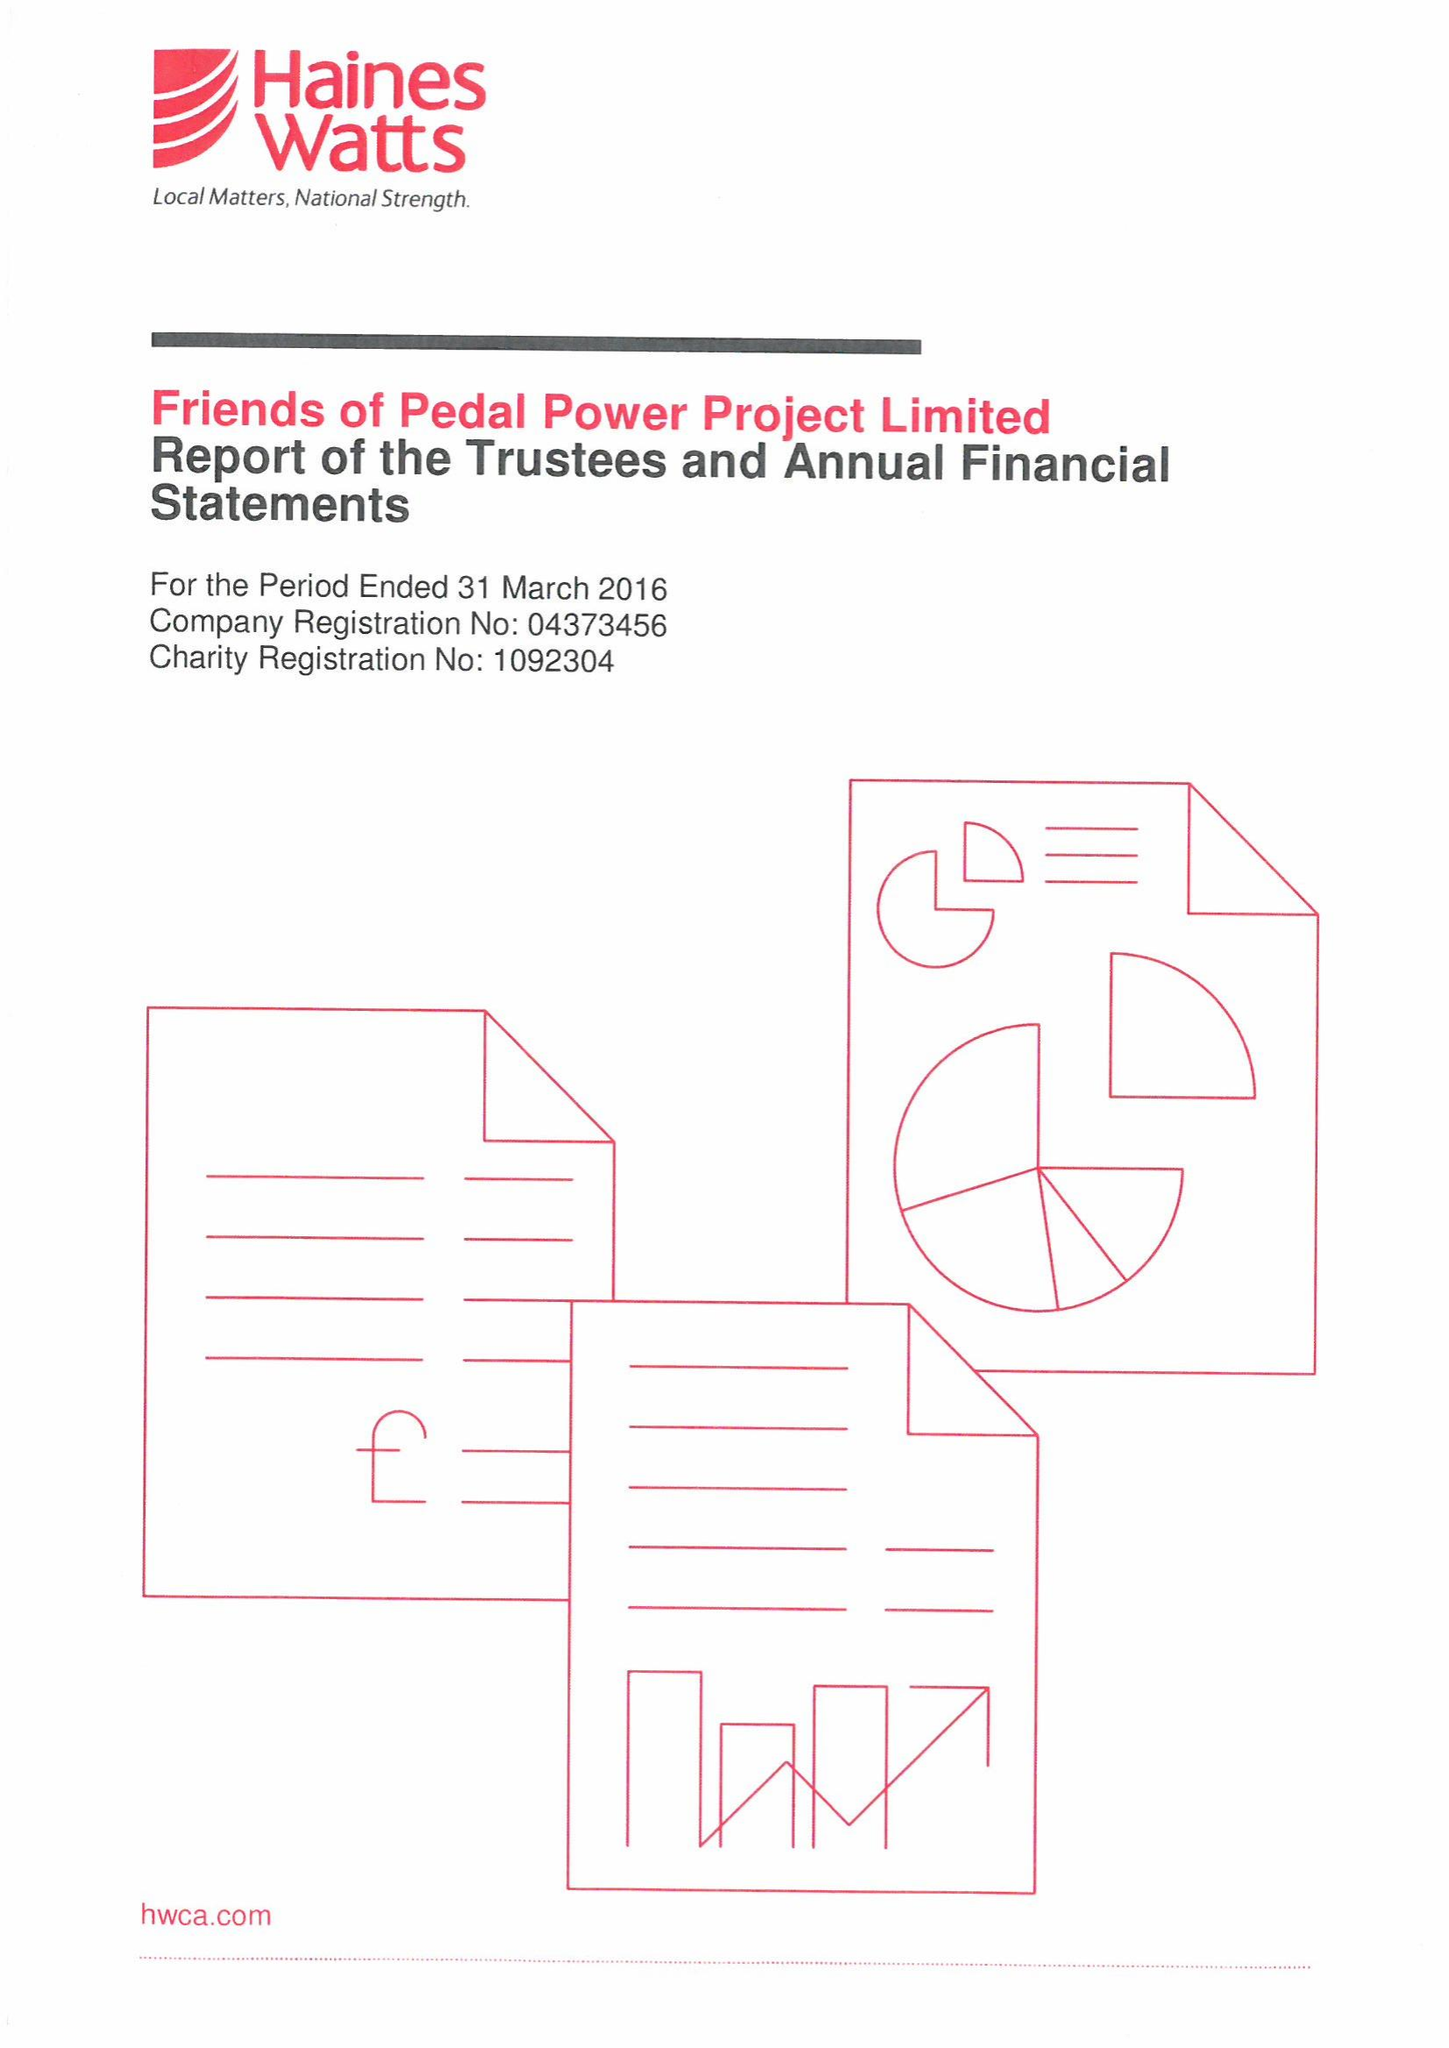What is the value for the charity_number?
Answer the question using a single word or phrase. 1092304 